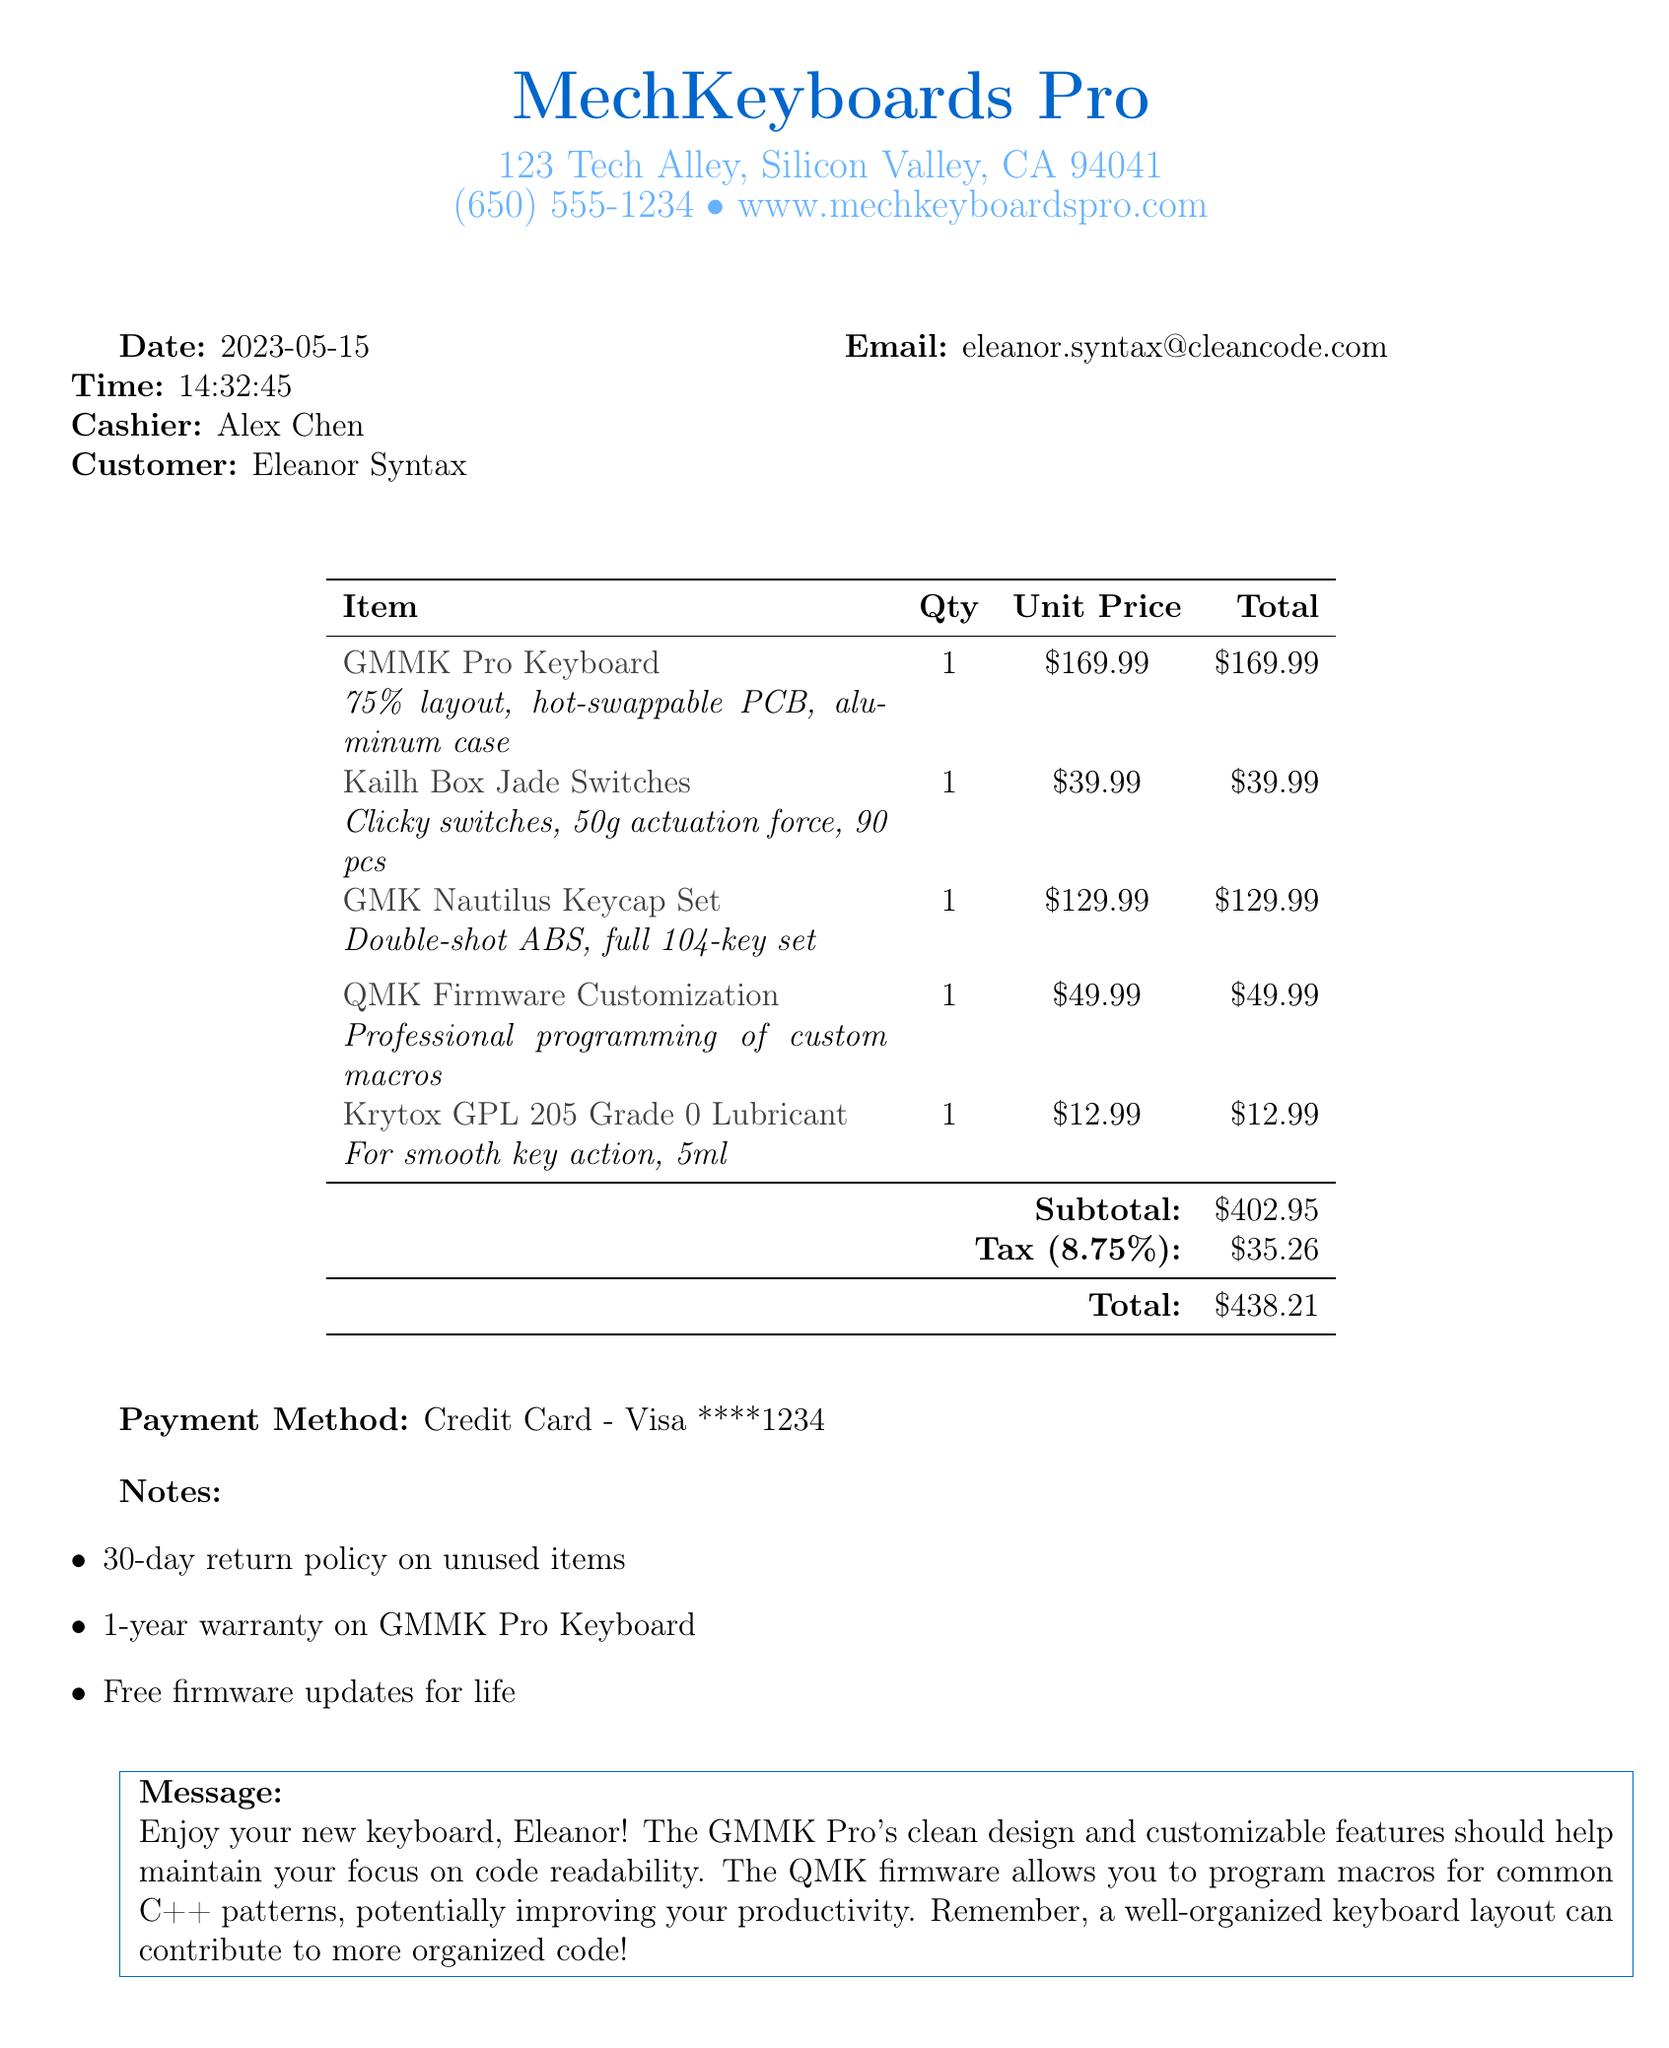What is the store name? The store name is listed prominently at the top of the receipt.
Answer: MechKeyboards Pro What is the total price? The total price is provided at the bottom of the receipt.
Answer: $438.21 Who was the cashier? The name of the cashier is mentioned in the receipt details.
Answer: Alex Chen What is the email address of the customer? The customer's email is specified in the customer information section.
Answer: eleanor.syntax@cleancode.com What is the quantity of Kailh Box Jade Switches purchased? The quantity is noted next to the item in the list.
Answer: 1 What is the tax rate applied to the purchase? The tax rate is mentioned directly on the receipt.
Answer: 8.75% What is the return policy duration for unused items? The return policy is listed in the notes section of the receipt.
Answer: 30-day What type of lubricant was purchased? The specific type of lubricant is included in the item description.
Answer: Krytox GPL 205 Grade 0 Lubricant What customization service was included in the purchase? The customization service is explicitly mentioned as a line item in the receipt.
Answer: QMK Firmware Customization 